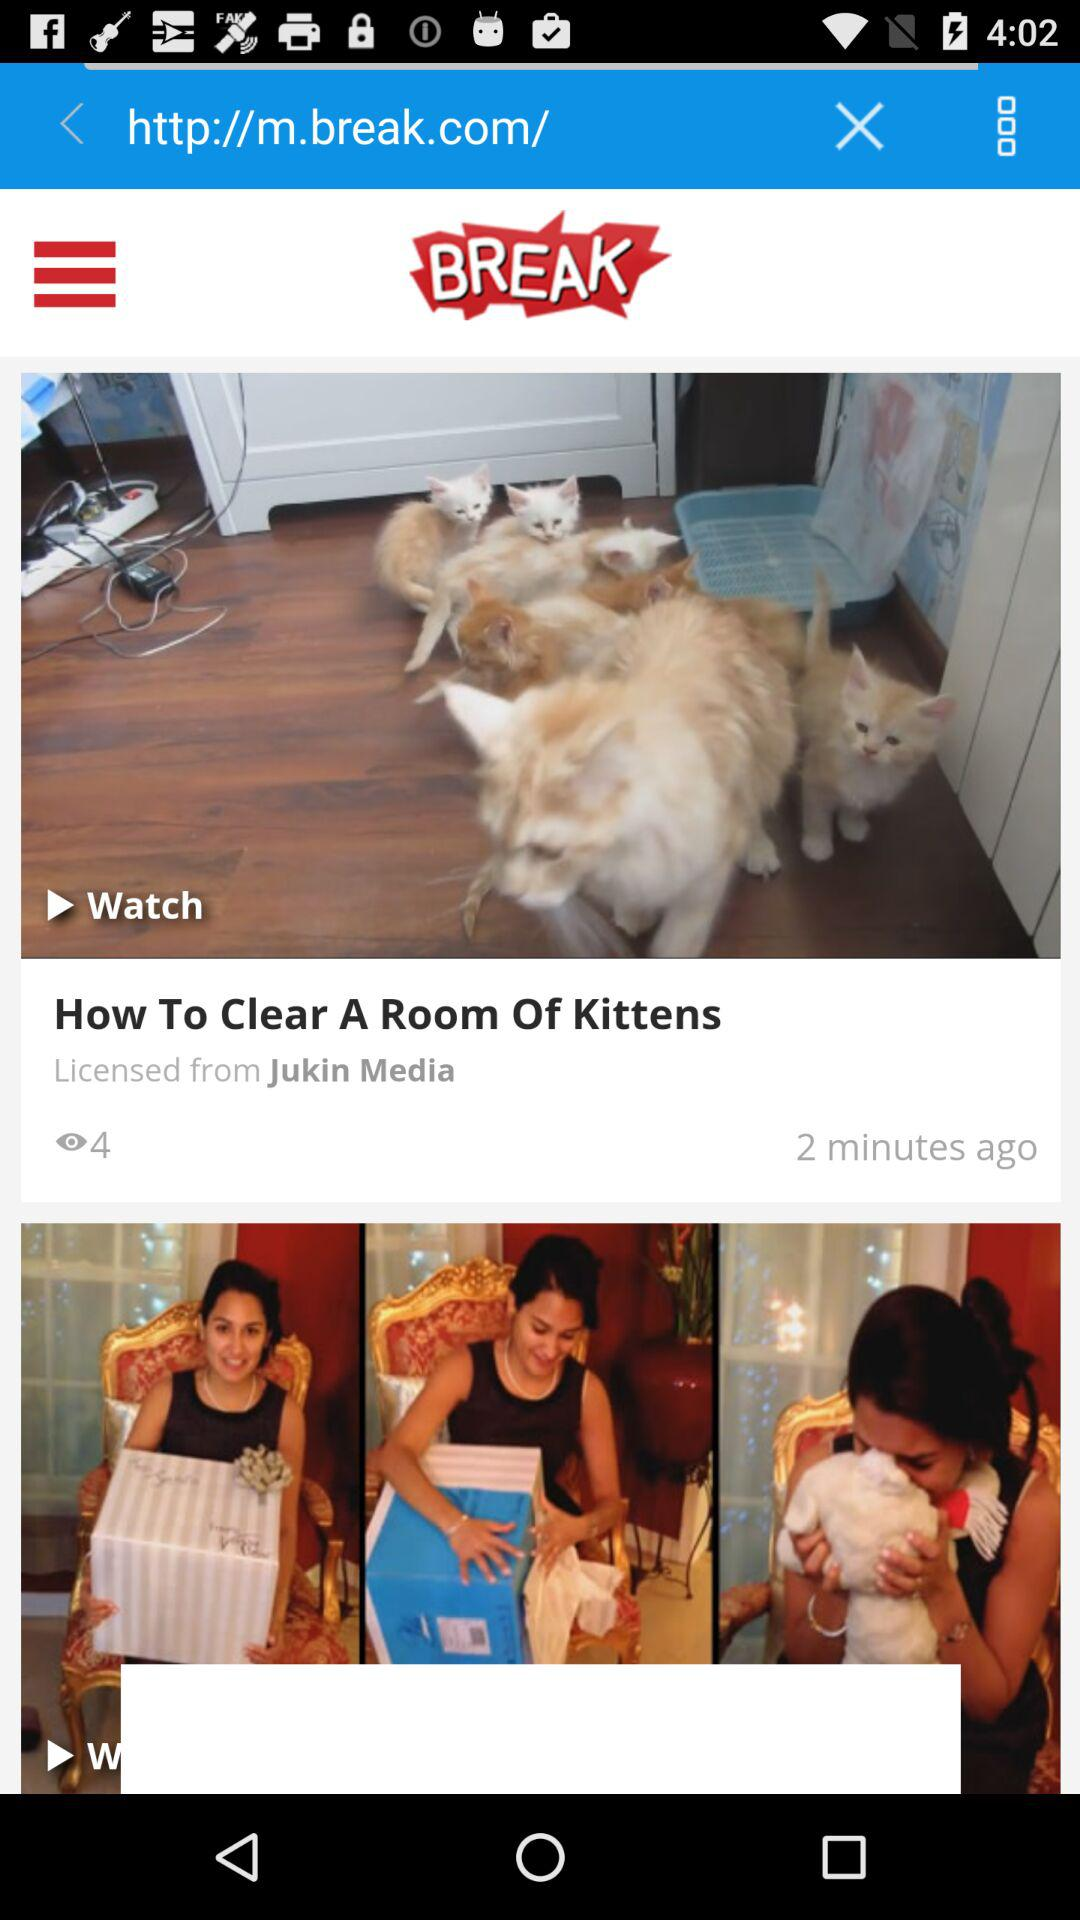How many views are there of "How To Clear A Room Of Kittens"? There are 4 views of "How To Clear A Room Of Kittens". 